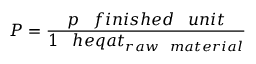Convert formula to latex. <formula><loc_0><loc_0><loc_500><loc_500>P = { \frac { p \, f i n i s h e d \, u n i t } { 1 \, h e q a t _ { r a w \, m a t e r i a l } } }</formula> 